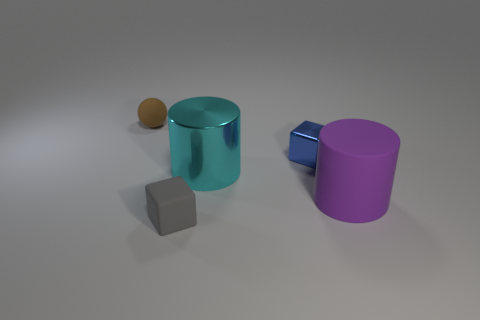Is there a blue object of the same size as the shiny block?
Keep it short and to the point. No. Do the big cyan cylinder and the cube that is in front of the purple cylinder have the same material?
Your answer should be compact. No. What is the small object that is on the left side of the gray block made of?
Offer a terse response. Rubber. The brown matte sphere has what size?
Your answer should be compact. Small. There is a metallic object that is in front of the blue thing; is its size the same as the matte object that is right of the tiny gray matte cube?
Give a very brief answer. Yes. There is another gray thing that is the same shape as the tiny metal object; what is its size?
Your response must be concise. Small. Does the cyan metallic thing have the same size as the rubber object that is in front of the purple rubber thing?
Provide a succinct answer. No. Is there a blue block behind the tiny brown rubber sphere to the left of the big cyan metal thing?
Your response must be concise. No. There is a large object to the right of the small metal thing; what is its shape?
Ensure brevity in your answer.  Cylinder. The small thing on the right side of the cylinder behind the purple matte cylinder is what color?
Offer a terse response. Blue. 